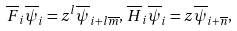<formula> <loc_0><loc_0><loc_500><loc_500>\overline { F } _ { i } \overline { \psi } _ { i } = z ^ { l } \overline { \psi } _ { i + l \overline { m } } , \, \overline { H } _ { i } \overline { \psi } _ { i } = z \overline { \psi } _ { i + \overline { n } } ,</formula> 